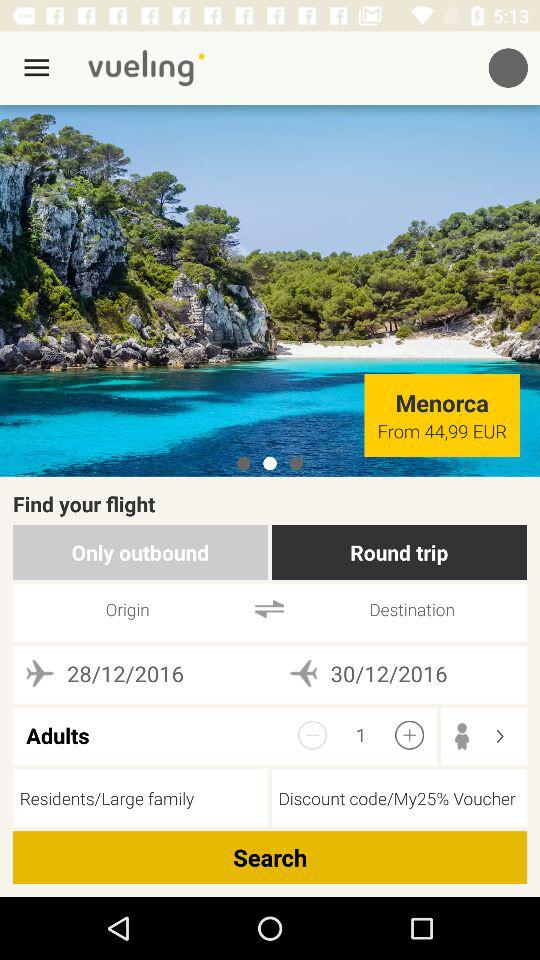What is the trip cost?
When the provided information is insufficient, respond with <no answer>. <no answer> 